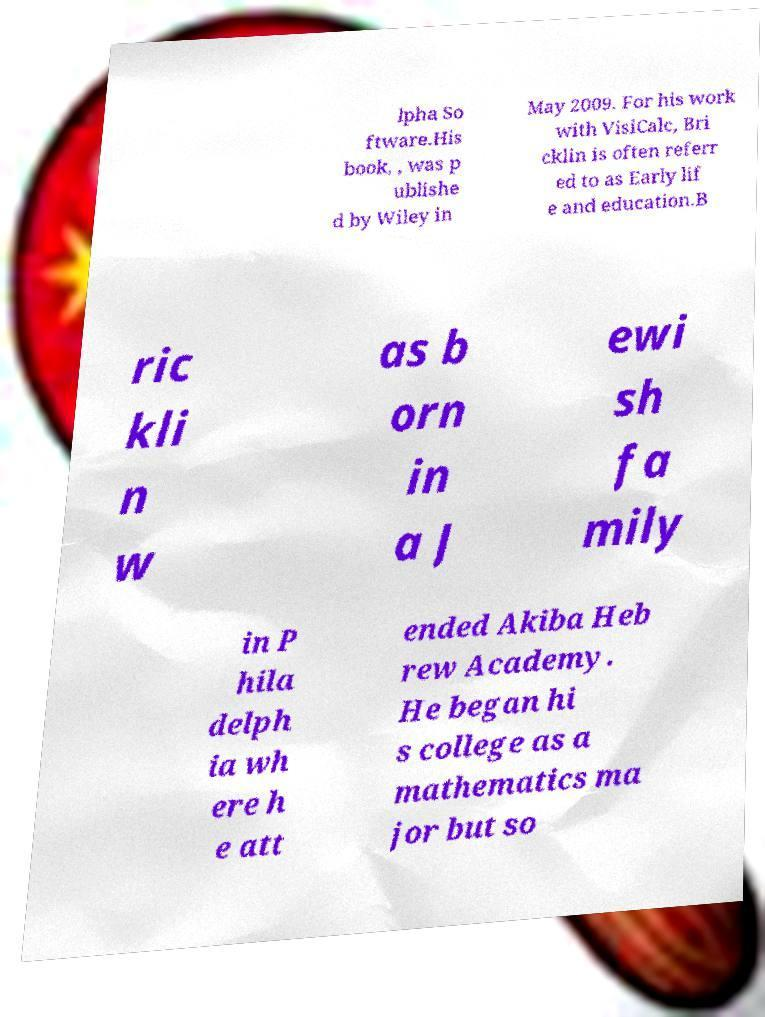For documentation purposes, I need the text within this image transcribed. Could you provide that? lpha So ftware.His book, , was p ublishe d by Wiley in May 2009. For his work with VisiCalc, Bri cklin is often referr ed to as Early lif e and education.B ric kli n w as b orn in a J ewi sh fa mily in P hila delph ia wh ere h e att ended Akiba Heb rew Academy. He began hi s college as a mathematics ma jor but so 